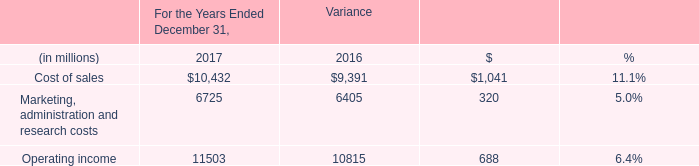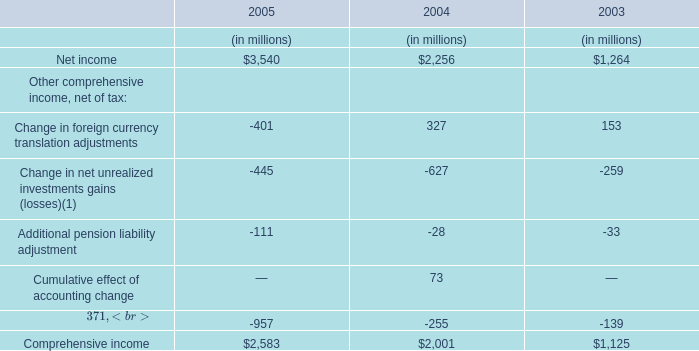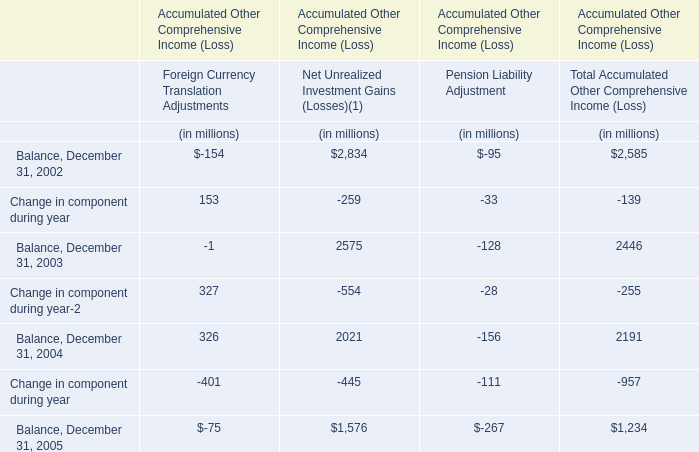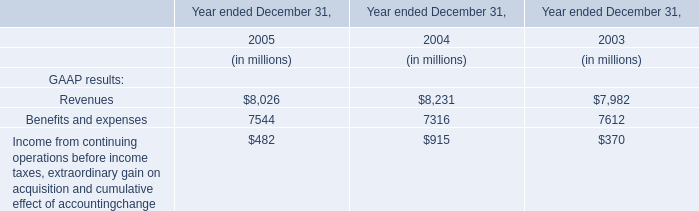Which year is Change in foreign currency translation adjustments the most? 
Answer: 2004. 